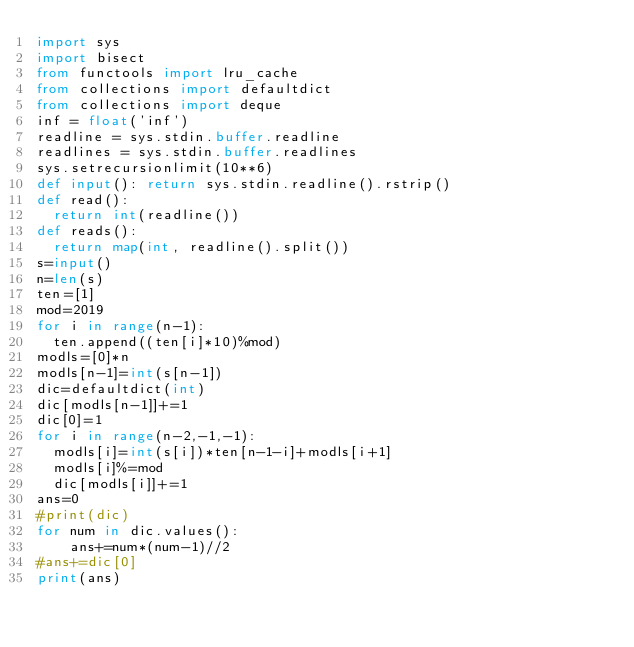Convert code to text. <code><loc_0><loc_0><loc_500><loc_500><_Python_>import sys
import bisect
from functools import lru_cache
from collections import defaultdict
from collections import deque
inf = float('inf')
readline = sys.stdin.buffer.readline
readlines = sys.stdin.buffer.readlines
sys.setrecursionlimit(10**6)
def input(): return sys.stdin.readline().rstrip()
def read():
  return int(readline())
def reads():
  return map(int, readline().split())
s=input()
n=len(s)
ten=[1]
mod=2019
for i in range(n-1):
  ten.append((ten[i]*10)%mod)
modls=[0]*n
modls[n-1]=int(s[n-1])
dic=defaultdict(int)
dic[modls[n-1]]+=1
dic[0]=1
for i in range(n-2,-1,-1):
  modls[i]=int(s[i])*ten[n-1-i]+modls[i+1]
  modls[i]%=mod
  dic[modls[i]]+=1
ans=0
#print(dic)
for num in dic.values():
	ans+=num*(num-1)//2
#ans+=dic[0]
print(ans)</code> 